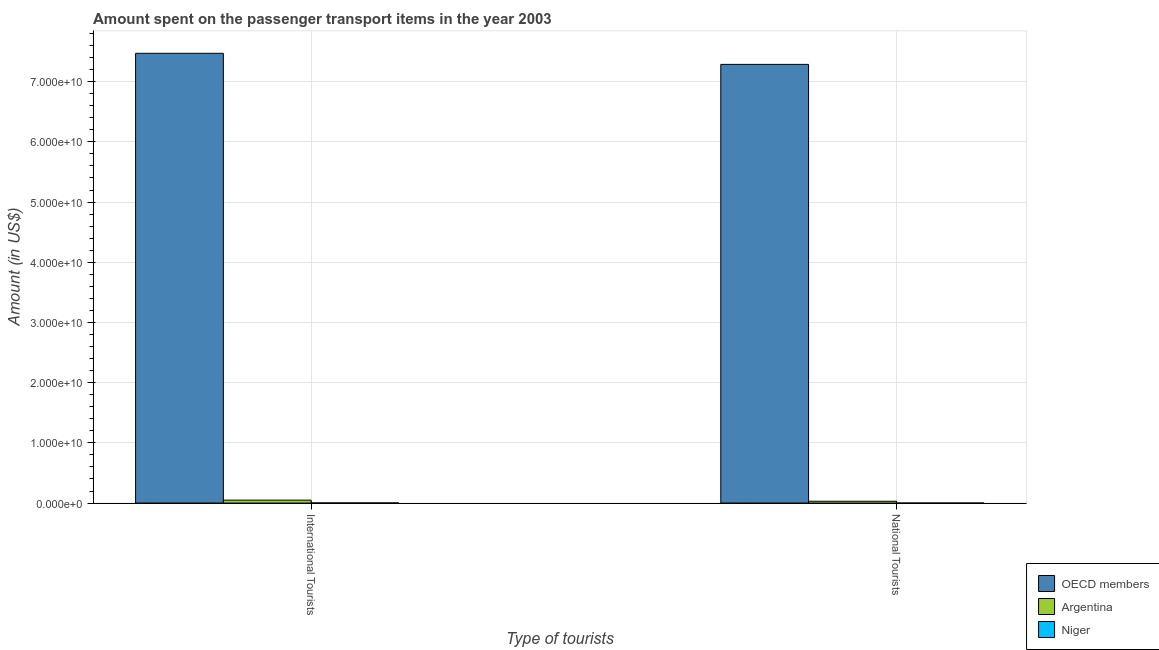Are the number of bars per tick equal to the number of legend labels?
Offer a very short reply. Yes. How many bars are there on the 2nd tick from the left?
Provide a short and direct response. 3. What is the label of the 2nd group of bars from the left?
Provide a succinct answer. National Tourists. What is the amount spent on transport items of national tourists in Argentina?
Provide a succinct answer. 3.00e+08. Across all countries, what is the maximum amount spent on transport items of national tourists?
Give a very brief answer. 7.29e+1. In which country was the amount spent on transport items of international tourists minimum?
Offer a terse response. Niger. What is the total amount spent on transport items of international tourists in the graph?
Offer a terse response. 7.52e+1. What is the difference between the amount spent on transport items of national tourists in Niger and that in OECD members?
Offer a terse response. -7.29e+1. What is the difference between the amount spent on transport items of international tourists in Niger and the amount spent on transport items of national tourists in Argentina?
Offer a very short reply. -2.83e+08. What is the average amount spent on transport items of national tourists per country?
Your response must be concise. 2.44e+1. What is the difference between the amount spent on transport items of international tourists and amount spent on transport items of national tourists in Niger?
Your answer should be very brief. 1.65e+07. What is the ratio of the amount spent on transport items of international tourists in Argentina to that in Niger?
Offer a very short reply. 28.59. Is the amount spent on transport items of international tourists in OECD members less than that in Argentina?
Keep it short and to the point. No. In how many countries, is the amount spent on transport items of national tourists greater than the average amount spent on transport items of national tourists taken over all countries?
Make the answer very short. 1. How many bars are there?
Make the answer very short. 6. What is the difference between two consecutive major ticks on the Y-axis?
Your answer should be very brief. 1.00e+1. Does the graph contain any zero values?
Keep it short and to the point. No. Does the graph contain grids?
Keep it short and to the point. Yes. Where does the legend appear in the graph?
Provide a short and direct response. Bottom right. How are the legend labels stacked?
Offer a terse response. Vertical. What is the title of the graph?
Your response must be concise. Amount spent on the passenger transport items in the year 2003. What is the label or title of the X-axis?
Provide a short and direct response. Type of tourists. What is the label or title of the Y-axis?
Ensure brevity in your answer.  Amount (in US$). What is the Amount (in US$) of OECD members in International Tourists?
Your response must be concise. 7.47e+1. What is the Amount (in US$) of Argentina in International Tourists?
Keep it short and to the point. 4.86e+08. What is the Amount (in US$) in Niger in International Tourists?
Provide a succinct answer. 1.70e+07. What is the Amount (in US$) of OECD members in National Tourists?
Ensure brevity in your answer.  7.29e+1. What is the Amount (in US$) of Argentina in National Tourists?
Your response must be concise. 3.00e+08. Across all Type of tourists, what is the maximum Amount (in US$) of OECD members?
Keep it short and to the point. 7.47e+1. Across all Type of tourists, what is the maximum Amount (in US$) in Argentina?
Keep it short and to the point. 4.86e+08. Across all Type of tourists, what is the maximum Amount (in US$) in Niger?
Provide a short and direct response. 1.70e+07. Across all Type of tourists, what is the minimum Amount (in US$) in OECD members?
Keep it short and to the point. 7.29e+1. Across all Type of tourists, what is the minimum Amount (in US$) of Argentina?
Provide a short and direct response. 3.00e+08. What is the total Amount (in US$) in OECD members in the graph?
Keep it short and to the point. 1.48e+11. What is the total Amount (in US$) of Argentina in the graph?
Ensure brevity in your answer.  7.86e+08. What is the total Amount (in US$) of Niger in the graph?
Offer a terse response. 1.75e+07. What is the difference between the Amount (in US$) of OECD members in International Tourists and that in National Tourists?
Make the answer very short. 1.84e+09. What is the difference between the Amount (in US$) in Argentina in International Tourists and that in National Tourists?
Offer a very short reply. 1.86e+08. What is the difference between the Amount (in US$) of Niger in International Tourists and that in National Tourists?
Ensure brevity in your answer.  1.65e+07. What is the difference between the Amount (in US$) of OECD members in International Tourists and the Amount (in US$) of Argentina in National Tourists?
Offer a terse response. 7.44e+1. What is the difference between the Amount (in US$) of OECD members in International Tourists and the Amount (in US$) of Niger in National Tourists?
Give a very brief answer. 7.47e+1. What is the difference between the Amount (in US$) in Argentina in International Tourists and the Amount (in US$) in Niger in National Tourists?
Make the answer very short. 4.86e+08. What is the average Amount (in US$) in OECD members per Type of tourists?
Your response must be concise. 7.38e+1. What is the average Amount (in US$) of Argentina per Type of tourists?
Give a very brief answer. 3.93e+08. What is the average Amount (in US$) of Niger per Type of tourists?
Ensure brevity in your answer.  8.75e+06. What is the difference between the Amount (in US$) in OECD members and Amount (in US$) in Argentina in International Tourists?
Your answer should be very brief. 7.42e+1. What is the difference between the Amount (in US$) of OECD members and Amount (in US$) of Niger in International Tourists?
Your answer should be very brief. 7.47e+1. What is the difference between the Amount (in US$) in Argentina and Amount (in US$) in Niger in International Tourists?
Your response must be concise. 4.69e+08. What is the difference between the Amount (in US$) in OECD members and Amount (in US$) in Argentina in National Tourists?
Your answer should be compact. 7.26e+1. What is the difference between the Amount (in US$) in OECD members and Amount (in US$) in Niger in National Tourists?
Make the answer very short. 7.29e+1. What is the difference between the Amount (in US$) in Argentina and Amount (in US$) in Niger in National Tourists?
Your answer should be very brief. 3.00e+08. What is the ratio of the Amount (in US$) of OECD members in International Tourists to that in National Tourists?
Offer a very short reply. 1.03. What is the ratio of the Amount (in US$) in Argentina in International Tourists to that in National Tourists?
Offer a terse response. 1.62. What is the difference between the highest and the second highest Amount (in US$) of OECD members?
Your answer should be compact. 1.84e+09. What is the difference between the highest and the second highest Amount (in US$) of Argentina?
Ensure brevity in your answer.  1.86e+08. What is the difference between the highest and the second highest Amount (in US$) of Niger?
Your answer should be compact. 1.65e+07. What is the difference between the highest and the lowest Amount (in US$) of OECD members?
Give a very brief answer. 1.84e+09. What is the difference between the highest and the lowest Amount (in US$) in Argentina?
Provide a short and direct response. 1.86e+08. What is the difference between the highest and the lowest Amount (in US$) in Niger?
Your answer should be compact. 1.65e+07. 